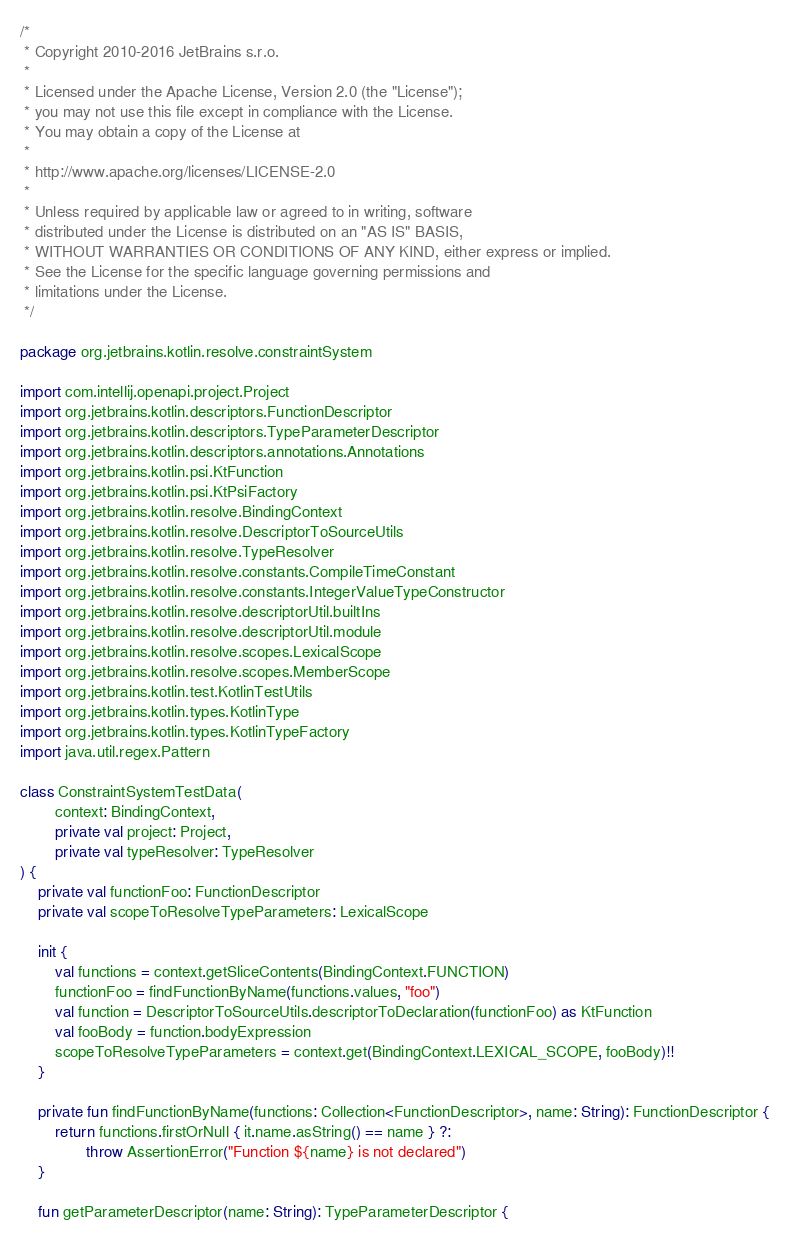<code> <loc_0><loc_0><loc_500><loc_500><_Kotlin_>/*
 * Copyright 2010-2016 JetBrains s.r.o.
 *
 * Licensed under the Apache License, Version 2.0 (the "License");
 * you may not use this file except in compliance with the License.
 * You may obtain a copy of the License at
 *
 * http://www.apache.org/licenses/LICENSE-2.0
 *
 * Unless required by applicable law or agreed to in writing, software
 * distributed under the License is distributed on an "AS IS" BASIS,
 * WITHOUT WARRANTIES OR CONDITIONS OF ANY KIND, either express or implied.
 * See the License for the specific language governing permissions and
 * limitations under the License.
 */

package org.jetbrains.kotlin.resolve.constraintSystem

import com.intellij.openapi.project.Project
import org.jetbrains.kotlin.descriptors.FunctionDescriptor
import org.jetbrains.kotlin.descriptors.TypeParameterDescriptor
import org.jetbrains.kotlin.descriptors.annotations.Annotations
import org.jetbrains.kotlin.psi.KtFunction
import org.jetbrains.kotlin.psi.KtPsiFactory
import org.jetbrains.kotlin.resolve.BindingContext
import org.jetbrains.kotlin.resolve.DescriptorToSourceUtils
import org.jetbrains.kotlin.resolve.TypeResolver
import org.jetbrains.kotlin.resolve.constants.CompileTimeConstant
import org.jetbrains.kotlin.resolve.constants.IntegerValueTypeConstructor
import org.jetbrains.kotlin.resolve.descriptorUtil.builtIns
import org.jetbrains.kotlin.resolve.descriptorUtil.module
import org.jetbrains.kotlin.resolve.scopes.LexicalScope
import org.jetbrains.kotlin.resolve.scopes.MemberScope
import org.jetbrains.kotlin.test.KotlinTestUtils
import org.jetbrains.kotlin.types.KotlinType
import org.jetbrains.kotlin.types.KotlinTypeFactory
import java.util.regex.Pattern

class ConstraintSystemTestData(
        context: BindingContext,
        private val project: Project,
        private val typeResolver: TypeResolver
) {
    private val functionFoo: FunctionDescriptor
    private val scopeToResolveTypeParameters: LexicalScope

    init {
        val functions = context.getSliceContents(BindingContext.FUNCTION)
        functionFoo = findFunctionByName(functions.values, "foo")
        val function = DescriptorToSourceUtils.descriptorToDeclaration(functionFoo) as KtFunction
        val fooBody = function.bodyExpression
        scopeToResolveTypeParameters = context.get(BindingContext.LEXICAL_SCOPE, fooBody)!!
    }

    private fun findFunctionByName(functions: Collection<FunctionDescriptor>, name: String): FunctionDescriptor {
        return functions.firstOrNull { it.name.asString() == name } ?:
               throw AssertionError("Function ${name} is not declared")
    }

    fun getParameterDescriptor(name: String): TypeParameterDescriptor {</code> 